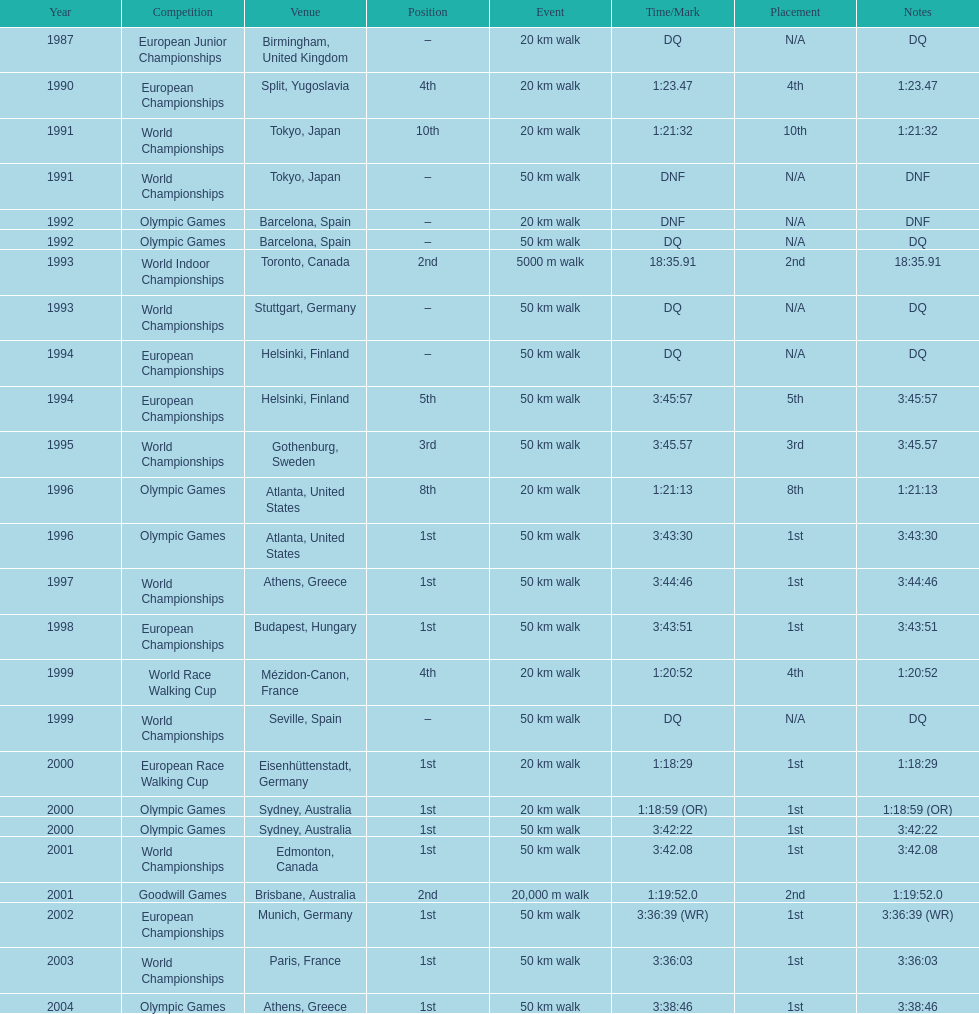What was the name of the competition that took place before the olympic games in 1996? World Championships. 